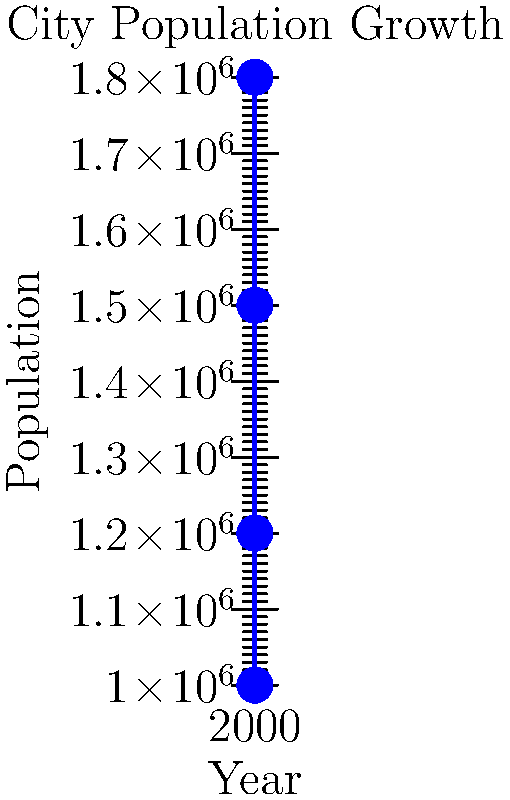A city's population has grown as shown in the graph above. If a city map from 1990 has a scale of 1:50,000, what should be the scale of a new map in 2020 to maintain the same population density representation? To solve this problem, we need to follow these steps:

1. Calculate the population growth rate from 1990 to 2020:
   Population in 2020: 1,800,000
   Population in 1990: 1,000,000
   Growth rate = 1,800,000 / 1,000,000 = 1.8

2. To maintain the same population density representation, the area of the map must increase by the same factor as the population growth.

3. The area scales with the square of the linear dimensions. So, we need to find the square root of the growth rate:
   $\sqrt{1.8} \approx 1.3416$

4. The new scale should be the original scale multiplied by this factor:
   New scale = 50,000 * 1.3416 ≈ 67,080

5. Round to a more practical scale: 1:67,000

Therefore, to maintain the same population density representation, the new map should have a scale of approximately 1:67,000.
Answer: 1:67,000 